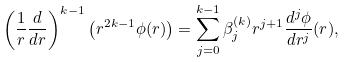Convert formula to latex. <formula><loc_0><loc_0><loc_500><loc_500>\left ( \frac { 1 } { r } \frac { d } { d r } \right ) ^ { k - 1 } \left ( r ^ { 2 k - 1 } \phi ( r ) \right ) & = \sum _ { j = 0 } ^ { k - 1 } \beta ^ { ( k ) } _ { j } r ^ { j + 1 } \frac { d ^ { j } \phi } { d r ^ { j } } ( r ) ,</formula> 